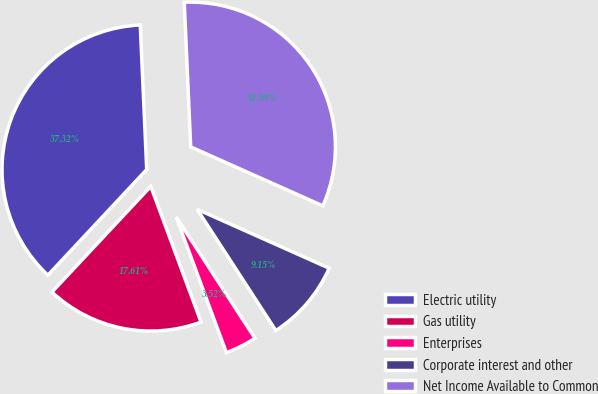Convert chart to OTSL. <chart><loc_0><loc_0><loc_500><loc_500><pie_chart><fcel>Electric utility<fcel>Gas utility<fcel>Enterprises<fcel>Corporate interest and other<fcel>Net Income Available to Common<nl><fcel>37.32%<fcel>17.61%<fcel>3.52%<fcel>9.15%<fcel>32.39%<nl></chart> 